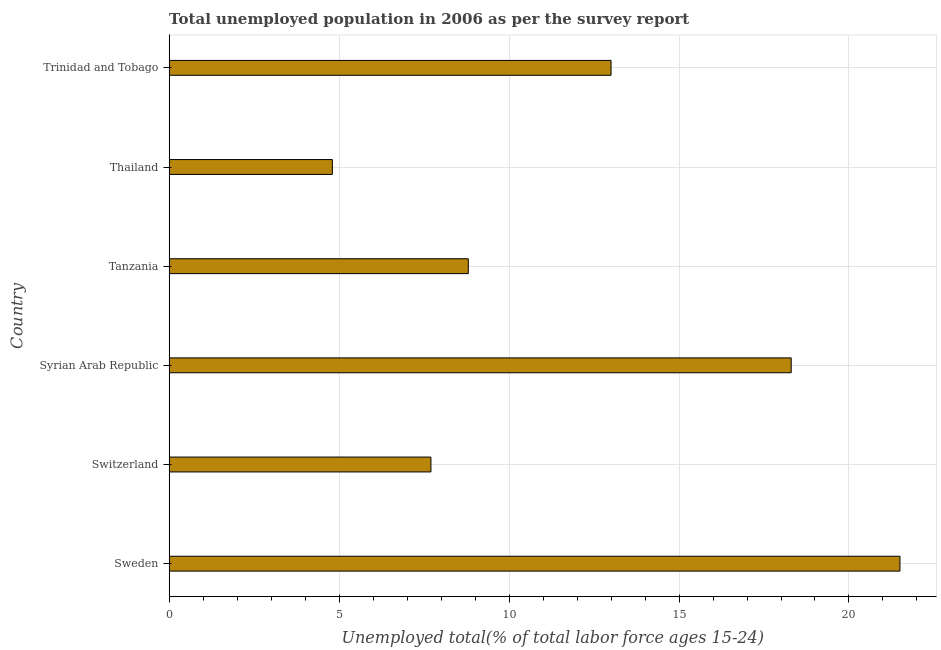Does the graph contain any zero values?
Your answer should be compact. No. What is the title of the graph?
Offer a very short reply. Total unemployed population in 2006 as per the survey report. What is the label or title of the X-axis?
Your answer should be very brief. Unemployed total(% of total labor force ages 15-24). What is the label or title of the Y-axis?
Keep it short and to the point. Country. What is the unemployed youth in Sweden?
Your response must be concise. 21.5. Across all countries, what is the maximum unemployed youth?
Provide a succinct answer. 21.5. Across all countries, what is the minimum unemployed youth?
Your response must be concise. 4.8. In which country was the unemployed youth maximum?
Your answer should be compact. Sweden. In which country was the unemployed youth minimum?
Keep it short and to the point. Thailand. What is the sum of the unemployed youth?
Your answer should be very brief. 74.1. What is the difference between the unemployed youth in Tanzania and Thailand?
Your response must be concise. 4. What is the average unemployed youth per country?
Make the answer very short. 12.35. What is the median unemployed youth?
Provide a succinct answer. 10.9. In how many countries, is the unemployed youth greater than 3 %?
Keep it short and to the point. 6. What is the ratio of the unemployed youth in Sweden to that in Trinidad and Tobago?
Your answer should be very brief. 1.65. Is the difference between the unemployed youth in Switzerland and Syrian Arab Republic greater than the difference between any two countries?
Make the answer very short. No. What is the difference between the highest and the second highest unemployed youth?
Your answer should be compact. 3.2. What is the difference between the highest and the lowest unemployed youth?
Your answer should be very brief. 16.7. Are all the bars in the graph horizontal?
Make the answer very short. Yes. How many countries are there in the graph?
Provide a succinct answer. 6. Are the values on the major ticks of X-axis written in scientific E-notation?
Offer a terse response. No. What is the Unemployed total(% of total labor force ages 15-24) of Switzerland?
Your response must be concise. 7.7. What is the Unemployed total(% of total labor force ages 15-24) in Syrian Arab Republic?
Provide a succinct answer. 18.3. What is the Unemployed total(% of total labor force ages 15-24) of Tanzania?
Provide a succinct answer. 8.8. What is the Unemployed total(% of total labor force ages 15-24) of Thailand?
Your response must be concise. 4.8. What is the difference between the Unemployed total(% of total labor force ages 15-24) in Sweden and Tanzania?
Your response must be concise. 12.7. What is the difference between the Unemployed total(% of total labor force ages 15-24) in Sweden and Trinidad and Tobago?
Ensure brevity in your answer.  8.5. What is the difference between the Unemployed total(% of total labor force ages 15-24) in Syrian Arab Republic and Tanzania?
Offer a terse response. 9.5. What is the difference between the Unemployed total(% of total labor force ages 15-24) in Syrian Arab Republic and Thailand?
Provide a short and direct response. 13.5. What is the difference between the Unemployed total(% of total labor force ages 15-24) in Syrian Arab Republic and Trinidad and Tobago?
Offer a very short reply. 5.3. What is the difference between the Unemployed total(% of total labor force ages 15-24) in Thailand and Trinidad and Tobago?
Make the answer very short. -8.2. What is the ratio of the Unemployed total(% of total labor force ages 15-24) in Sweden to that in Switzerland?
Ensure brevity in your answer.  2.79. What is the ratio of the Unemployed total(% of total labor force ages 15-24) in Sweden to that in Syrian Arab Republic?
Offer a terse response. 1.18. What is the ratio of the Unemployed total(% of total labor force ages 15-24) in Sweden to that in Tanzania?
Your answer should be compact. 2.44. What is the ratio of the Unemployed total(% of total labor force ages 15-24) in Sweden to that in Thailand?
Your response must be concise. 4.48. What is the ratio of the Unemployed total(% of total labor force ages 15-24) in Sweden to that in Trinidad and Tobago?
Offer a terse response. 1.65. What is the ratio of the Unemployed total(% of total labor force ages 15-24) in Switzerland to that in Syrian Arab Republic?
Ensure brevity in your answer.  0.42. What is the ratio of the Unemployed total(% of total labor force ages 15-24) in Switzerland to that in Tanzania?
Your response must be concise. 0.88. What is the ratio of the Unemployed total(% of total labor force ages 15-24) in Switzerland to that in Thailand?
Offer a very short reply. 1.6. What is the ratio of the Unemployed total(% of total labor force ages 15-24) in Switzerland to that in Trinidad and Tobago?
Offer a very short reply. 0.59. What is the ratio of the Unemployed total(% of total labor force ages 15-24) in Syrian Arab Republic to that in Tanzania?
Provide a short and direct response. 2.08. What is the ratio of the Unemployed total(% of total labor force ages 15-24) in Syrian Arab Republic to that in Thailand?
Your answer should be very brief. 3.81. What is the ratio of the Unemployed total(% of total labor force ages 15-24) in Syrian Arab Republic to that in Trinidad and Tobago?
Provide a succinct answer. 1.41. What is the ratio of the Unemployed total(% of total labor force ages 15-24) in Tanzania to that in Thailand?
Make the answer very short. 1.83. What is the ratio of the Unemployed total(% of total labor force ages 15-24) in Tanzania to that in Trinidad and Tobago?
Offer a very short reply. 0.68. What is the ratio of the Unemployed total(% of total labor force ages 15-24) in Thailand to that in Trinidad and Tobago?
Provide a short and direct response. 0.37. 